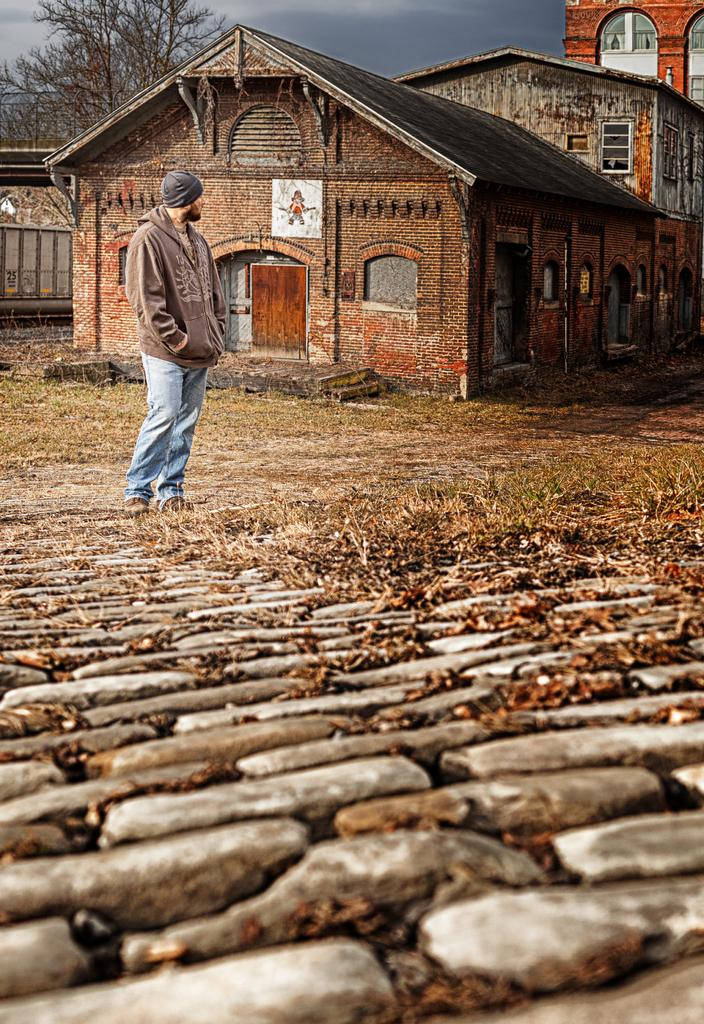What is the man in the image wearing on his head? The man is wearing a cap in the image. Where is the man standing in the image? The man is standing on the ground in the image. What type of structures can be seen in the image? There are buildings with windows in the image. What type of vegetation is present in the image? There are trees and grass in the image. What is visible in the background of the image? The sky is visible in the background of the image. Can you tell me how many airplanes are flying in the image? There are no airplanes visible in the image; it only features a man, buildings, trees, grass, and the sky. 